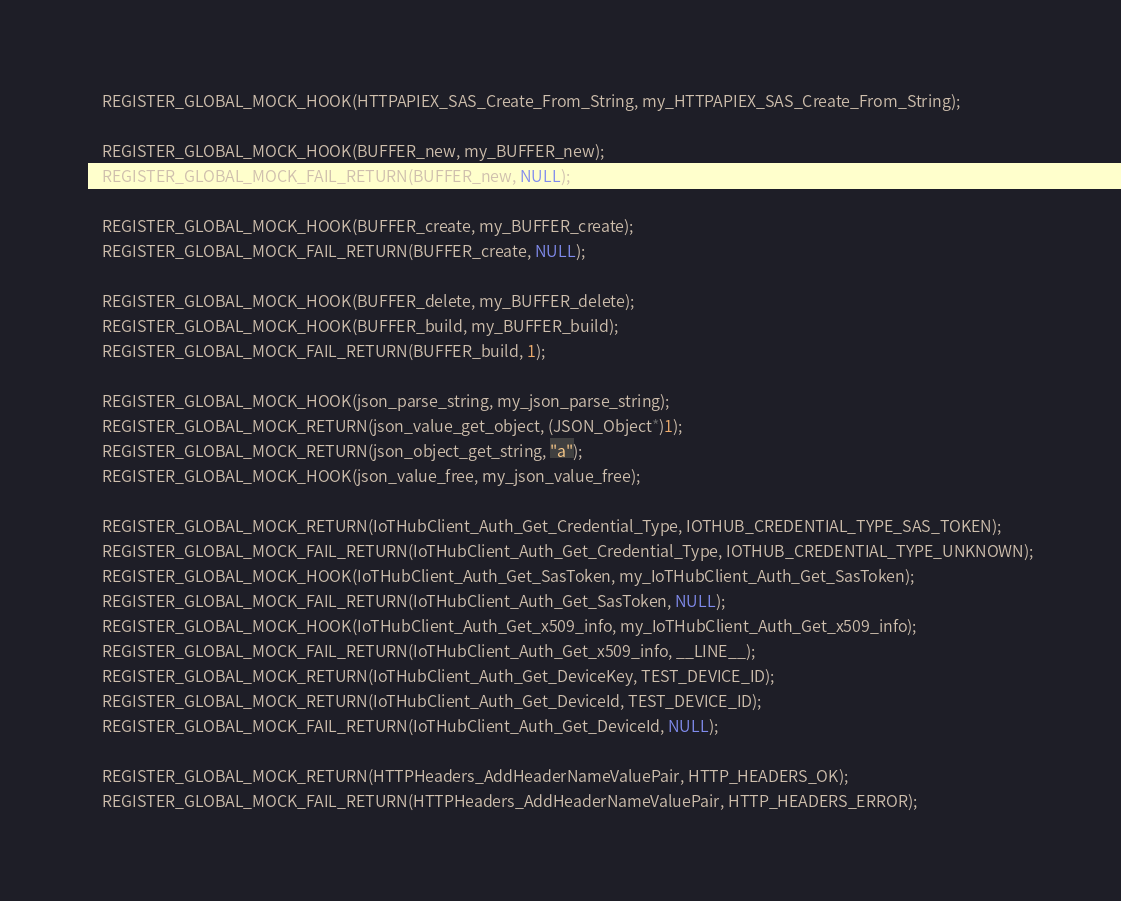Convert code to text. <code><loc_0><loc_0><loc_500><loc_500><_C_>    REGISTER_GLOBAL_MOCK_HOOK(HTTPAPIEX_SAS_Create_From_String, my_HTTPAPIEX_SAS_Create_From_String);

    REGISTER_GLOBAL_MOCK_HOOK(BUFFER_new, my_BUFFER_new);
    REGISTER_GLOBAL_MOCK_FAIL_RETURN(BUFFER_new, NULL);
    
    REGISTER_GLOBAL_MOCK_HOOK(BUFFER_create, my_BUFFER_create);
    REGISTER_GLOBAL_MOCK_FAIL_RETURN(BUFFER_create, NULL);

    REGISTER_GLOBAL_MOCK_HOOK(BUFFER_delete, my_BUFFER_delete);
    REGISTER_GLOBAL_MOCK_HOOK(BUFFER_build, my_BUFFER_build);
    REGISTER_GLOBAL_MOCK_FAIL_RETURN(BUFFER_build, 1);

    REGISTER_GLOBAL_MOCK_HOOK(json_parse_string, my_json_parse_string);
    REGISTER_GLOBAL_MOCK_RETURN(json_value_get_object, (JSON_Object*)1);
    REGISTER_GLOBAL_MOCK_RETURN(json_object_get_string, "a");
    REGISTER_GLOBAL_MOCK_HOOK(json_value_free, my_json_value_free);

    REGISTER_GLOBAL_MOCK_RETURN(IoTHubClient_Auth_Get_Credential_Type, IOTHUB_CREDENTIAL_TYPE_SAS_TOKEN);
    REGISTER_GLOBAL_MOCK_FAIL_RETURN(IoTHubClient_Auth_Get_Credential_Type, IOTHUB_CREDENTIAL_TYPE_UNKNOWN);
    REGISTER_GLOBAL_MOCK_HOOK(IoTHubClient_Auth_Get_SasToken, my_IoTHubClient_Auth_Get_SasToken);
    REGISTER_GLOBAL_MOCK_FAIL_RETURN(IoTHubClient_Auth_Get_SasToken, NULL);
    REGISTER_GLOBAL_MOCK_HOOK(IoTHubClient_Auth_Get_x509_info, my_IoTHubClient_Auth_Get_x509_info);
    REGISTER_GLOBAL_MOCK_FAIL_RETURN(IoTHubClient_Auth_Get_x509_info, __LINE__);
    REGISTER_GLOBAL_MOCK_RETURN(IoTHubClient_Auth_Get_DeviceKey, TEST_DEVICE_ID);
    REGISTER_GLOBAL_MOCK_RETURN(IoTHubClient_Auth_Get_DeviceId, TEST_DEVICE_ID);
    REGISTER_GLOBAL_MOCK_FAIL_RETURN(IoTHubClient_Auth_Get_DeviceId, NULL);

    REGISTER_GLOBAL_MOCK_RETURN(HTTPHeaders_AddHeaderNameValuePair, HTTP_HEADERS_OK);
    REGISTER_GLOBAL_MOCK_FAIL_RETURN(HTTPHeaders_AddHeaderNameValuePair, HTTP_HEADERS_ERROR);
</code> 